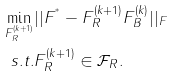<formula> <loc_0><loc_0><loc_500><loc_500>\min _ { F _ { R } ^ { ( k + 1 ) } } & | | F ^ { ^ { * } } - F _ { R } ^ { ( k + 1 ) } F _ { B } ^ { ( k ) } | | _ { F } \\ s . t . & F _ { R } ^ { ( k + 1 ) } \in \mathcal { F } _ { R } .</formula> 